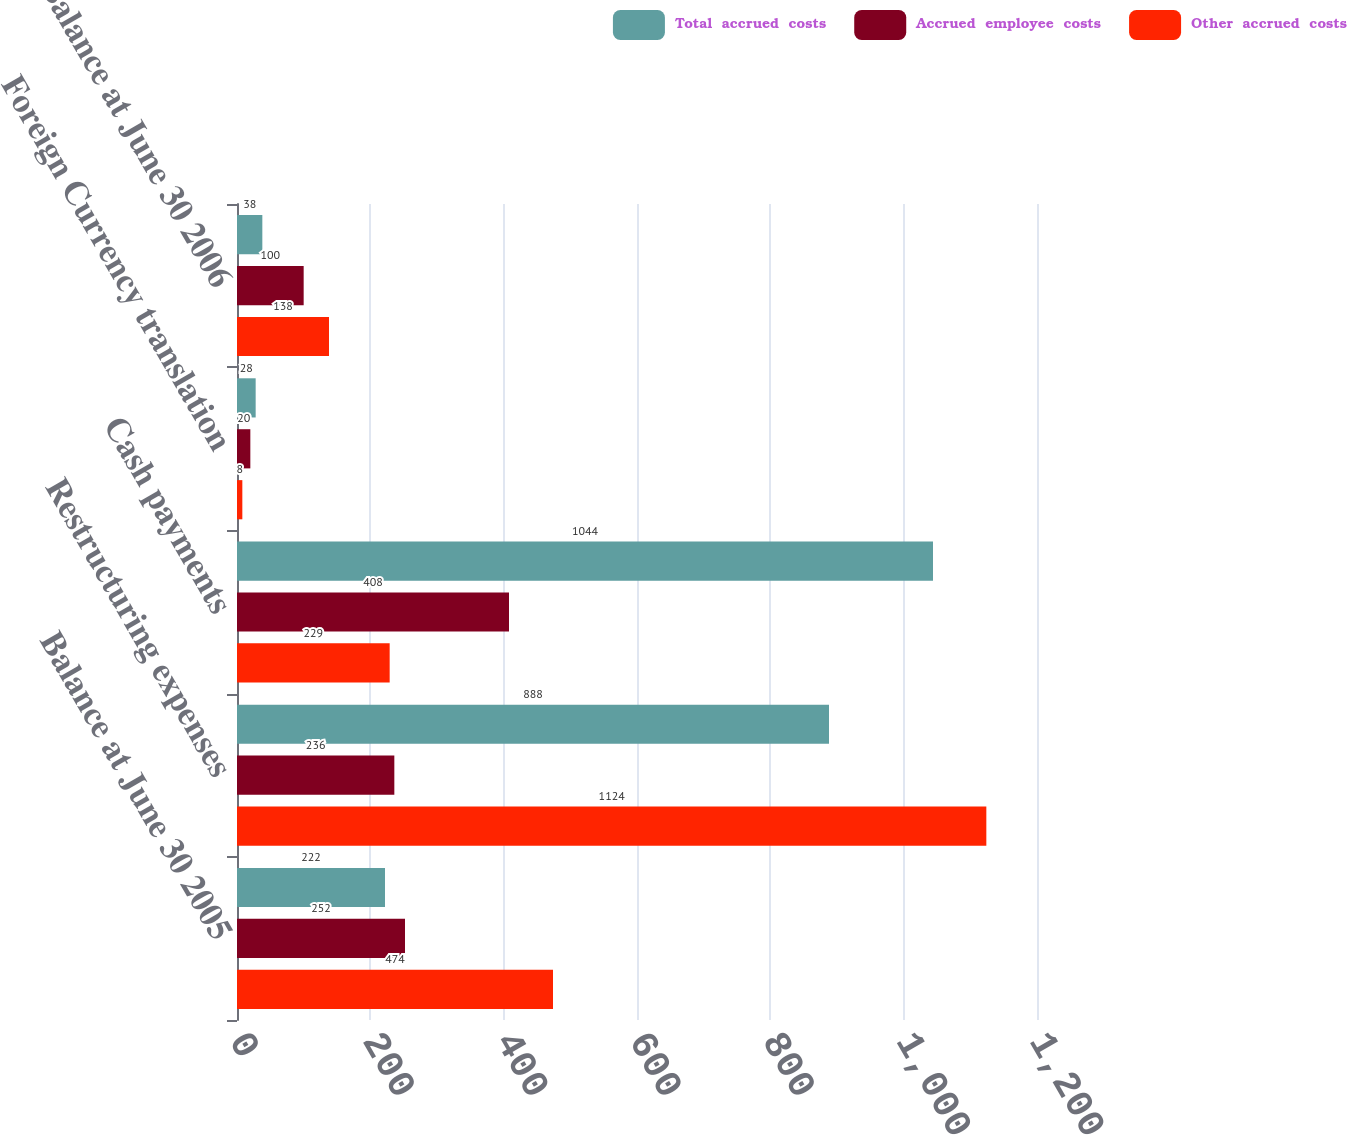Convert chart. <chart><loc_0><loc_0><loc_500><loc_500><stacked_bar_chart><ecel><fcel>Balance at June 30 2005<fcel>Restructuring expenses<fcel>Cash payments<fcel>Foreign Currency translation<fcel>Balance at June 30 2006<nl><fcel>Total  accrued  costs<fcel>222<fcel>888<fcel>1044<fcel>28<fcel>38<nl><fcel>Accrued  employee  costs<fcel>252<fcel>236<fcel>408<fcel>20<fcel>100<nl><fcel>Other  accrued  costs<fcel>474<fcel>1124<fcel>229<fcel>8<fcel>138<nl></chart> 